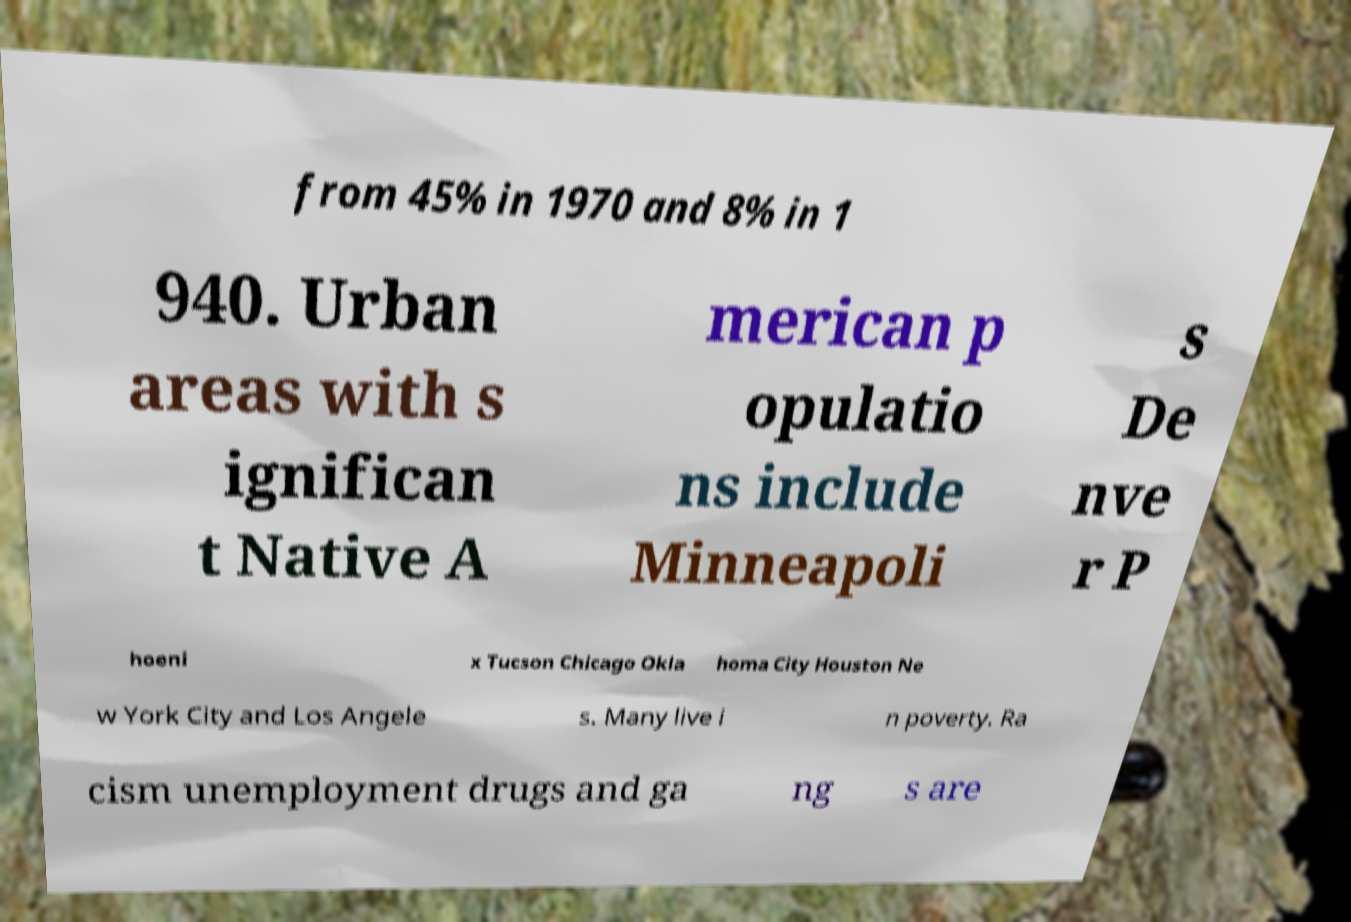Please read and relay the text visible in this image. What does it say? from 45% in 1970 and 8% in 1 940. Urban areas with s ignifican t Native A merican p opulatio ns include Minneapoli s De nve r P hoeni x Tucson Chicago Okla homa City Houston Ne w York City and Los Angele s. Many live i n poverty. Ra cism unemployment drugs and ga ng s are 